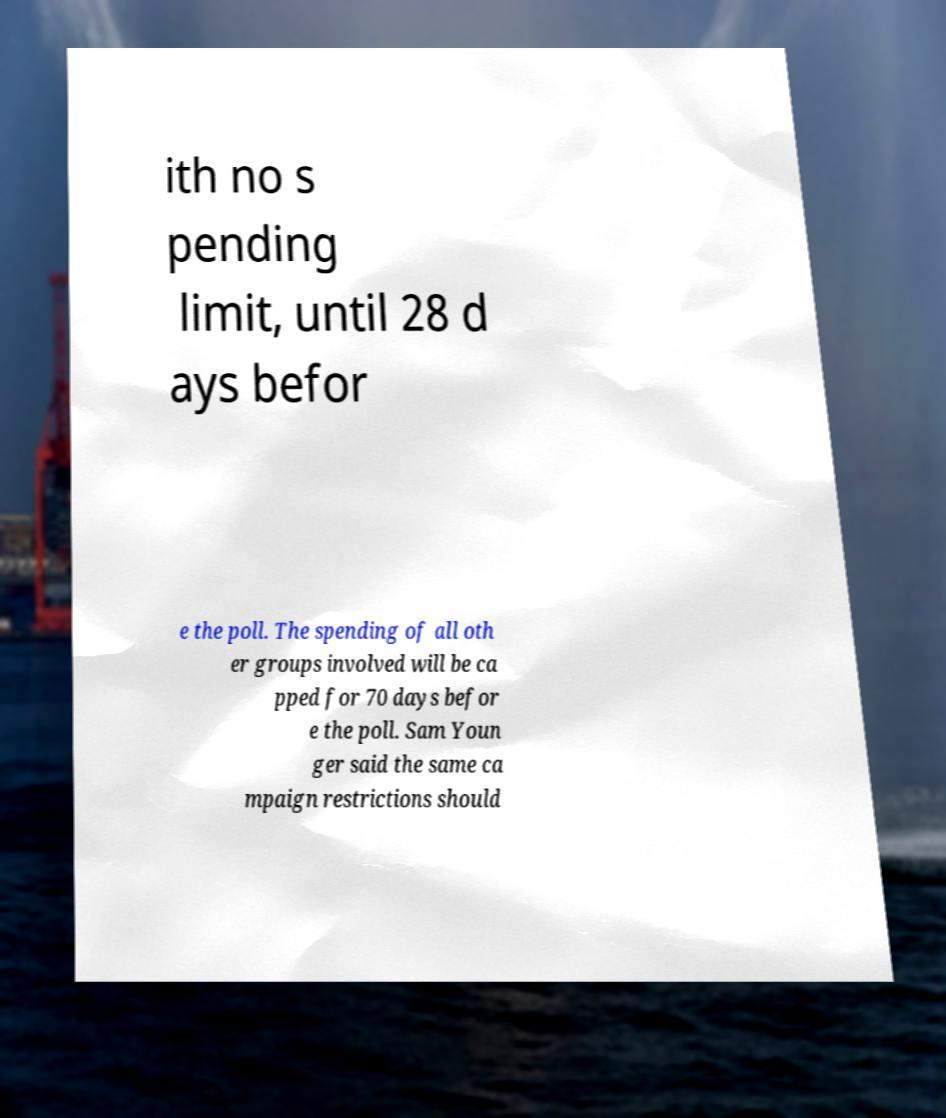Please identify and transcribe the text found in this image. ith no s pending limit, until 28 d ays befor e the poll. The spending of all oth er groups involved will be ca pped for 70 days befor e the poll. Sam Youn ger said the same ca mpaign restrictions should 